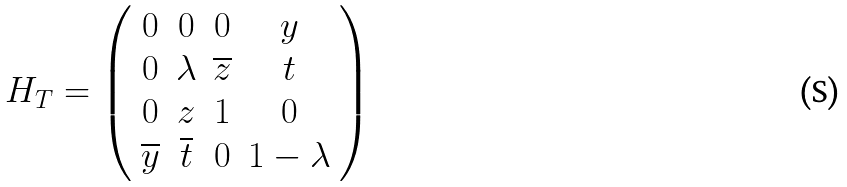Convert formula to latex. <formula><loc_0><loc_0><loc_500><loc_500>H _ { T } = \left ( \begin{array} { c c c c } 0 & 0 & 0 & y \\ 0 & \lambda & \overline { z } & t \\ 0 & z & 1 & 0 \\ \overline { y } & \overline { t } & 0 & 1 - \lambda \end{array} \right )</formula> 